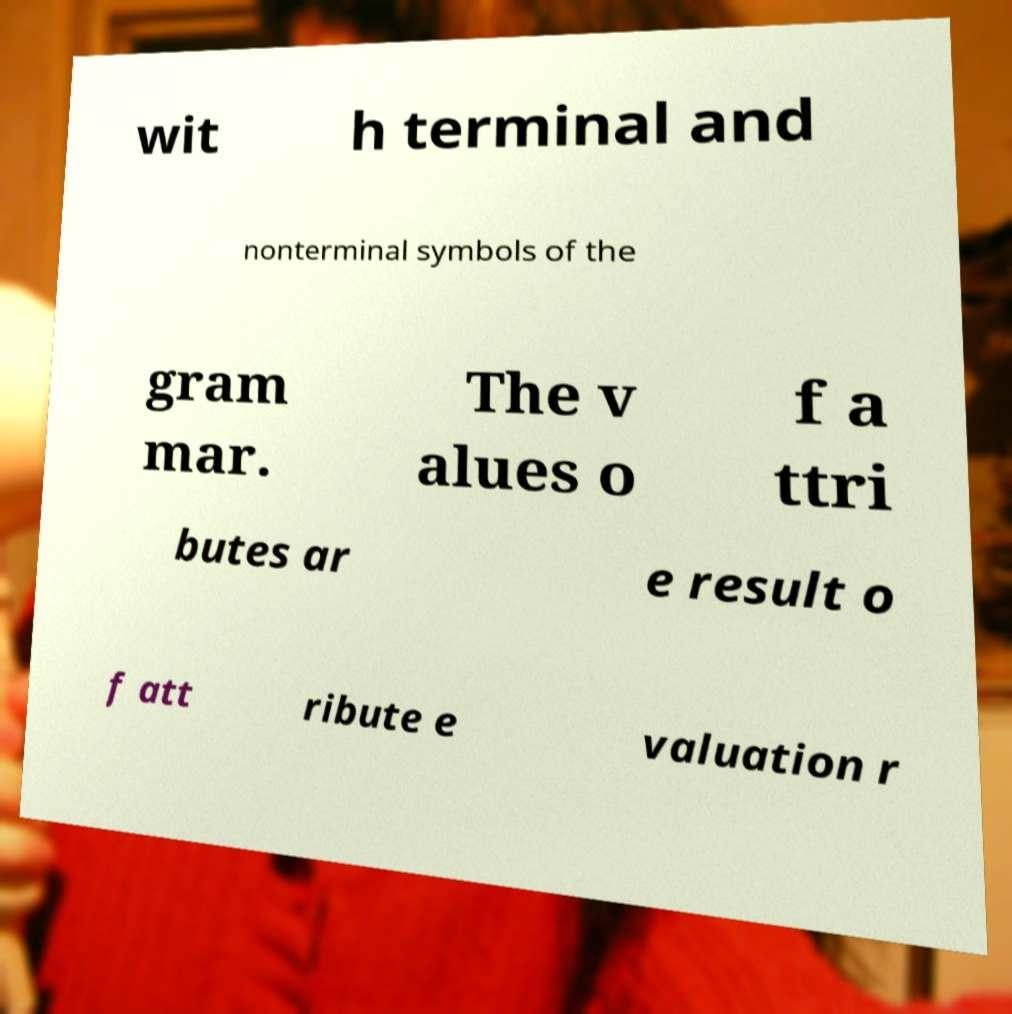Please read and relay the text visible in this image. What does it say? wit h terminal and nonterminal symbols of the gram mar. The v alues o f a ttri butes ar e result o f att ribute e valuation r 